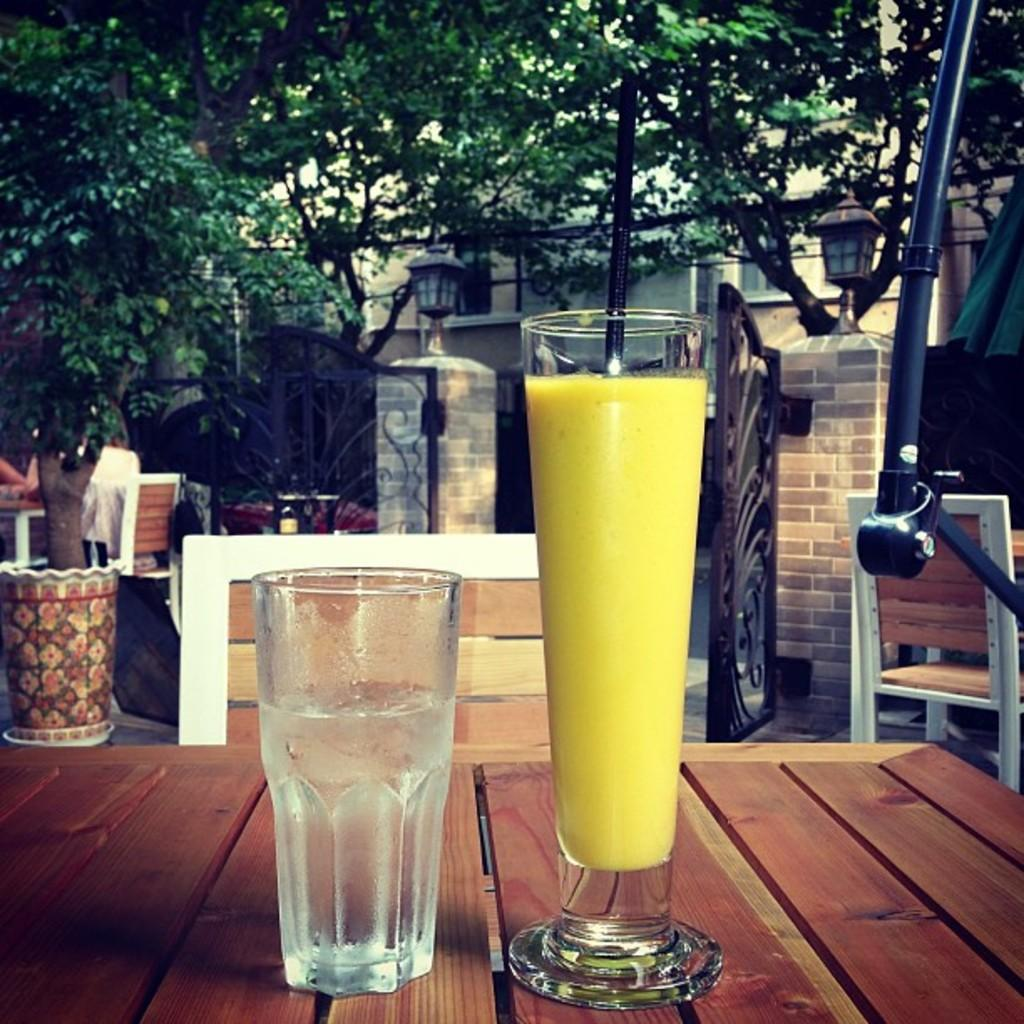What is in the glasses that are visible in the image? There are two glasses with a drink in the image. Where are the glasses located? The glasses are on a table. What can be seen in the background of the image? There are chairs, a building, trees, lights, and other objects visible in the background. Can you find the receipt for the drinks on the table in the image? There is no receipt present in the image. Who is the aunt sitting in the middle chair in the background of the image? There is no aunt or middle chair visible in the image. 